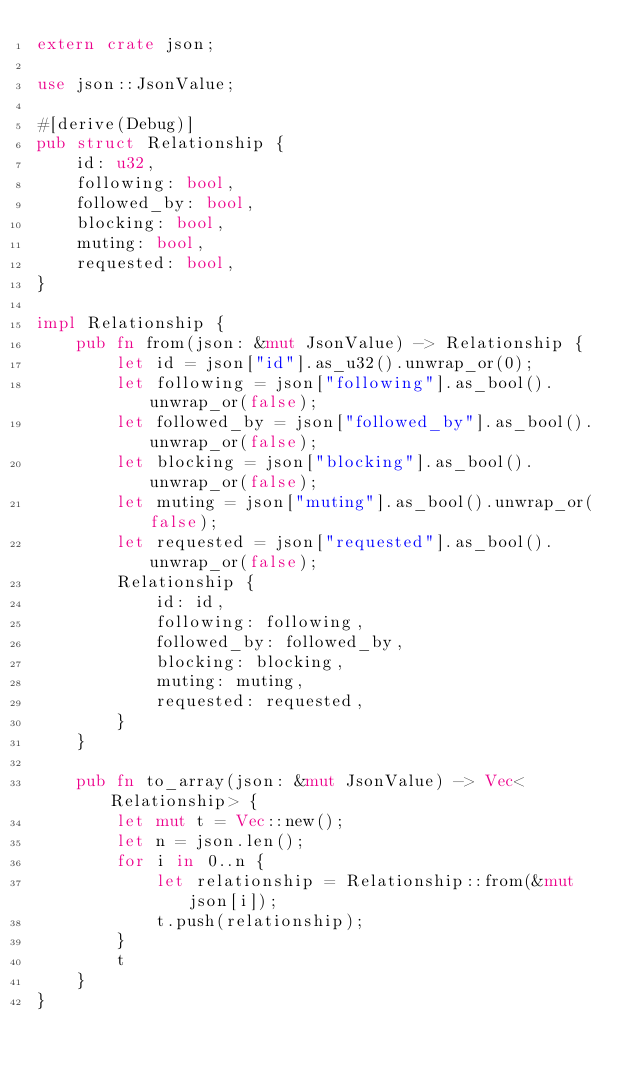Convert code to text. <code><loc_0><loc_0><loc_500><loc_500><_Rust_>extern crate json;

use json::JsonValue;

#[derive(Debug)]
pub struct Relationship {
    id: u32,
    following: bool,
    followed_by: bool,
    blocking: bool,
    muting: bool,
    requested: bool,
}

impl Relationship {
    pub fn from(json: &mut JsonValue) -> Relationship {
        let id = json["id"].as_u32().unwrap_or(0);
        let following = json["following"].as_bool().unwrap_or(false);
        let followed_by = json["followed_by"].as_bool().unwrap_or(false);
        let blocking = json["blocking"].as_bool().unwrap_or(false);
        let muting = json["muting"].as_bool().unwrap_or(false);
        let requested = json["requested"].as_bool().unwrap_or(false);
        Relationship {
            id: id,
            following: following,
            followed_by: followed_by,
            blocking: blocking,
            muting: muting,
            requested: requested,
        }
    }

    pub fn to_array(json: &mut JsonValue) -> Vec<Relationship> {
        let mut t = Vec::new();
        let n = json.len();
        for i in 0..n {
            let relationship = Relationship::from(&mut json[i]);
            t.push(relationship);
        }
        t
    }
}
</code> 